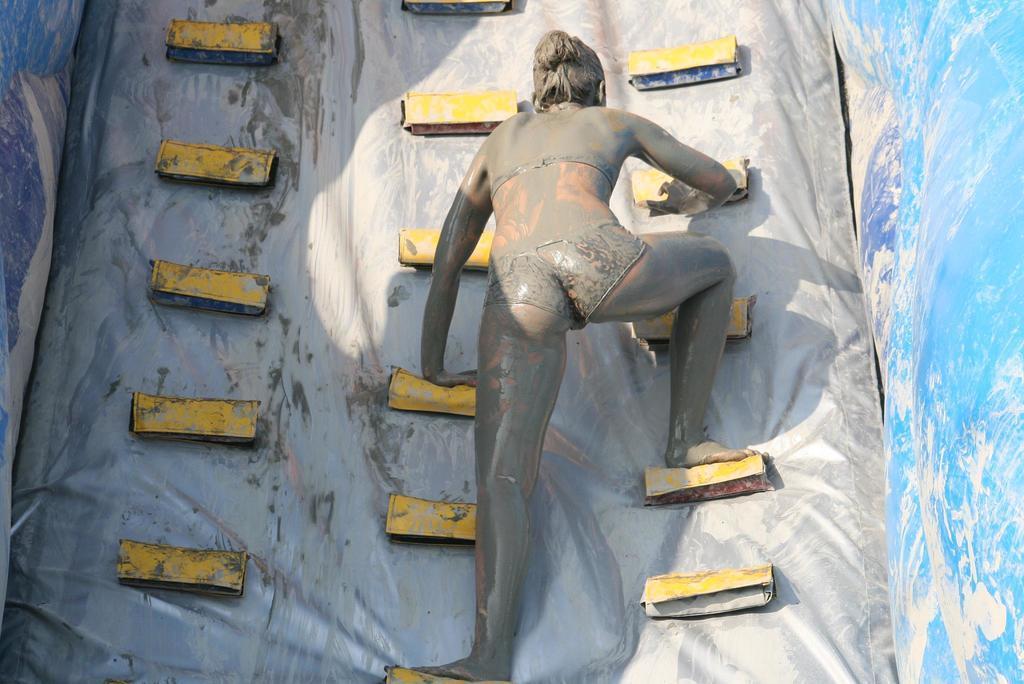Can you describe this image briefly? There is a woman playing climbing game. 